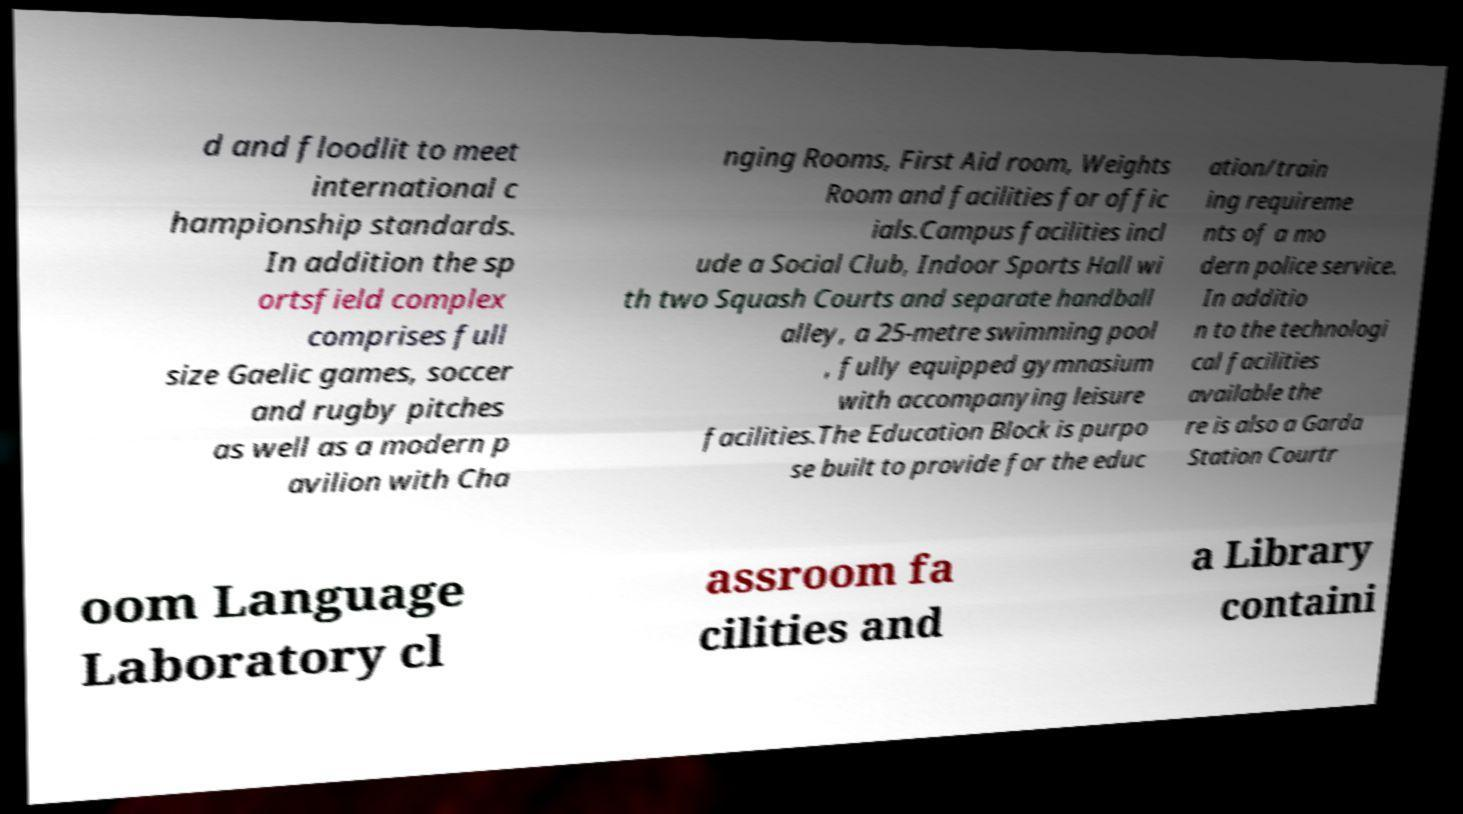Could you assist in decoding the text presented in this image and type it out clearly? d and floodlit to meet international c hampionship standards. In addition the sp ortsfield complex comprises full size Gaelic games, soccer and rugby pitches as well as a modern p avilion with Cha nging Rooms, First Aid room, Weights Room and facilities for offic ials.Campus facilities incl ude a Social Club, Indoor Sports Hall wi th two Squash Courts and separate handball alley, a 25-metre swimming pool , fully equipped gymnasium with accompanying leisure facilities.The Education Block is purpo se built to provide for the educ ation/train ing requireme nts of a mo dern police service. In additio n to the technologi cal facilities available the re is also a Garda Station Courtr oom Language Laboratory cl assroom fa cilities and a Library containi 